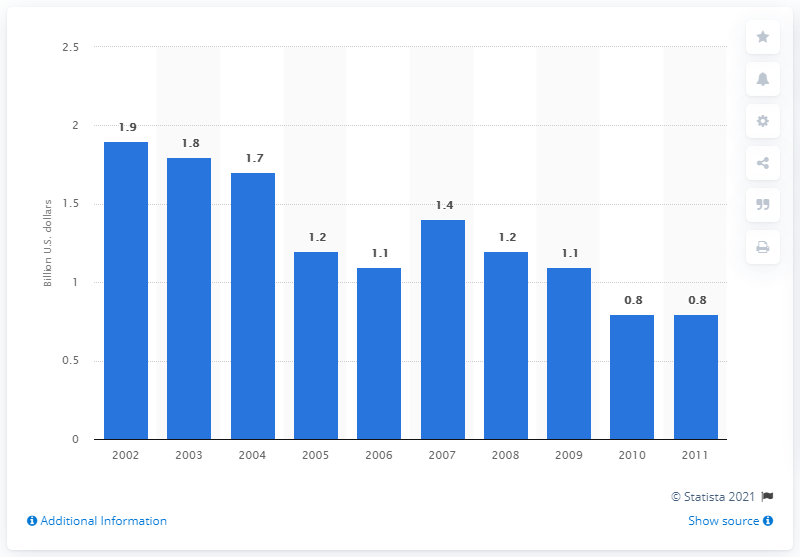Give some essential details in this illustration. In 2009, the value of U.S. product shipments of vacuum cleaners was approximately 1.1 billion dollars. 